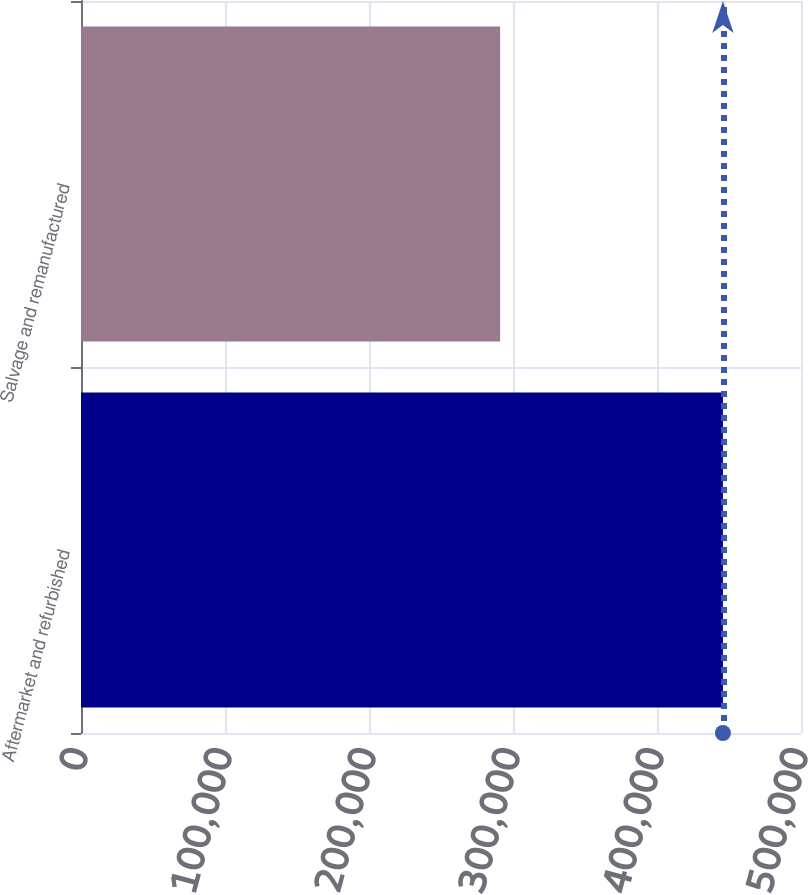Convert chart. <chart><loc_0><loc_0><loc_500><loc_500><bar_chart><fcel>Aftermarket and refurbished<fcel>Salvage and remanufactured<nl><fcel>445787<fcel>291059<nl></chart> 